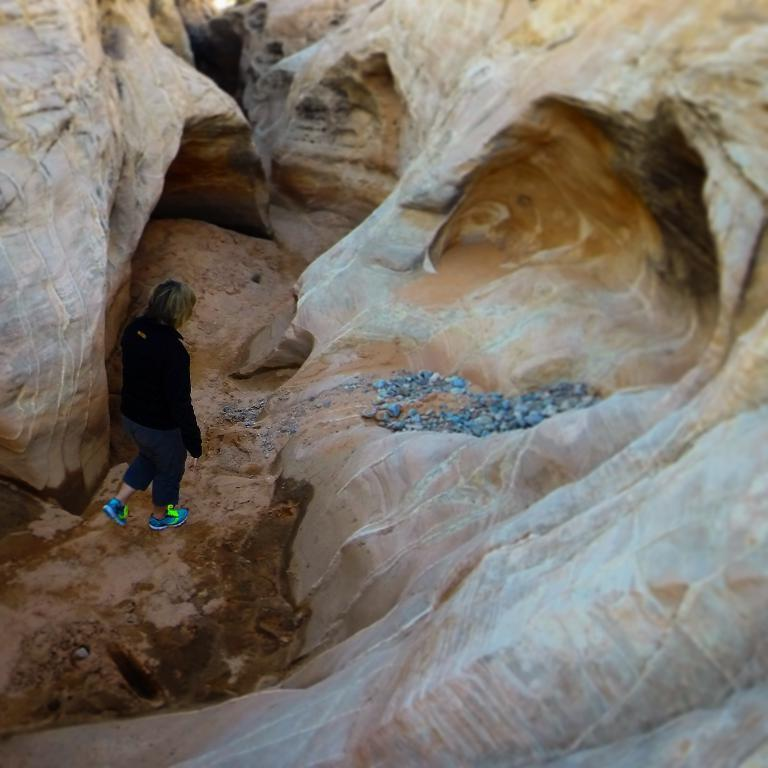What is the person in the image doing? There is a person walking on the road in the image. What natural feature can be seen in the background of the image? Mountains are visible in the image. What type of terrain is present in the image? Stones are present in the image. Can you determine the time of day the image was taken? The image was likely taken during the day, as there is no indication of darkness or artificial lighting. How many bikes are parked in the park in the image? There are no bikes or park present in the image; it features a person walking on a road with mountains in the background. 